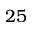Convert formula to latex. <formula><loc_0><loc_0><loc_500><loc_500>2 5</formula> 